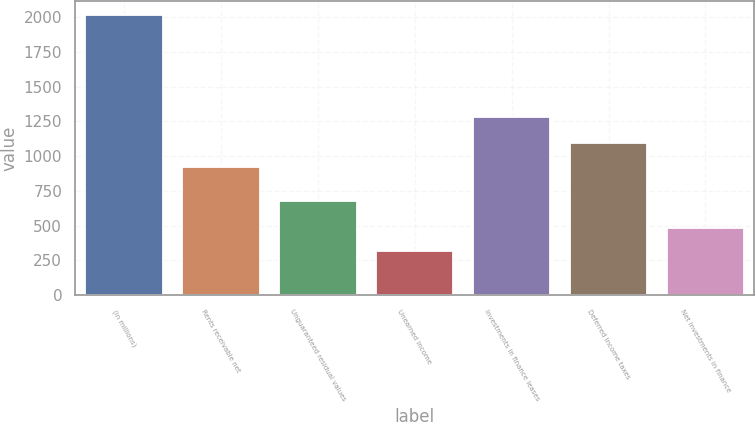<chart> <loc_0><loc_0><loc_500><loc_500><bar_chart><fcel>(in millions)<fcel>Rents receivable net<fcel>Unguaranteed residual values<fcel>Unearned income<fcel>Investments in finance leases<fcel>Deferred income taxes<fcel>Net investments in finance<nl><fcel>2015<fcel>923<fcel>674<fcel>316<fcel>1281<fcel>1092.9<fcel>485.9<nl></chart> 